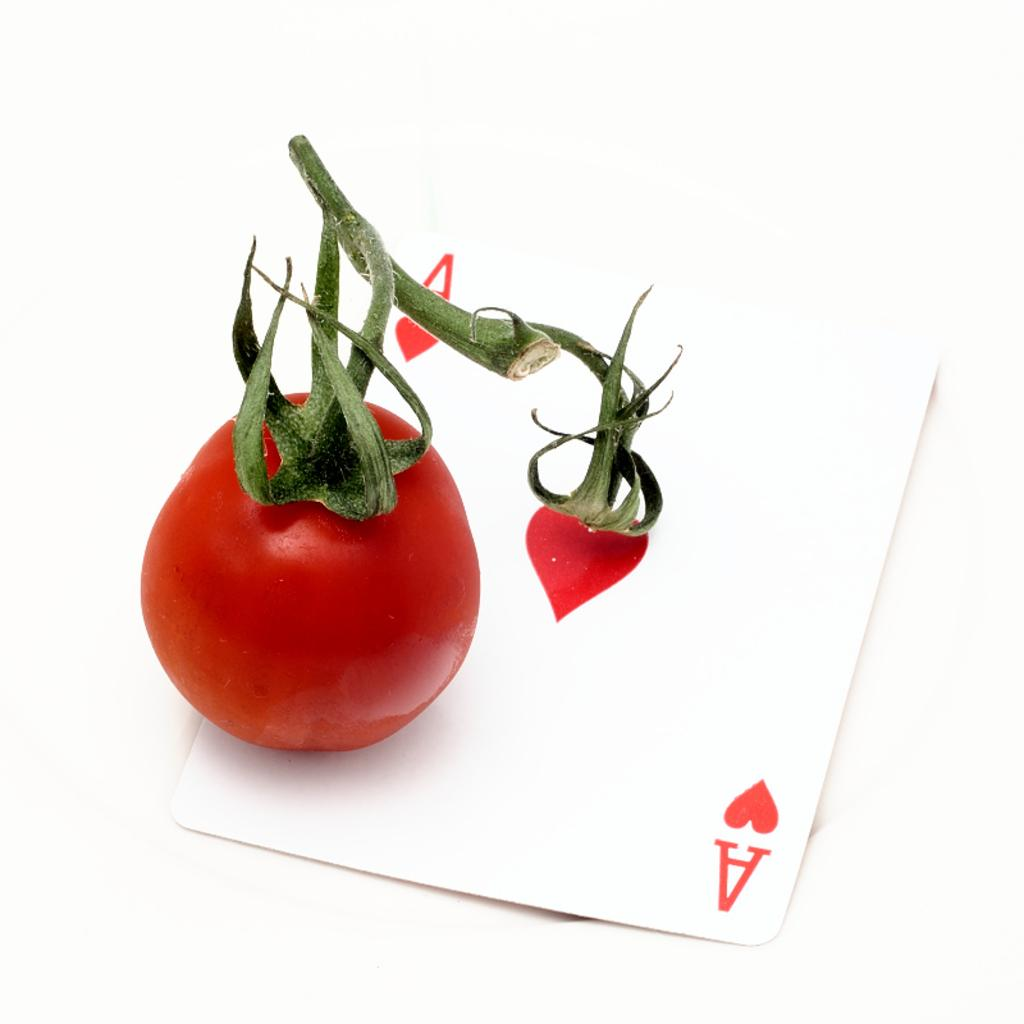What is depicted on the playing card in the image? There is a playing card in the image, and it has a tomato on it. What color is the tomato on the playing card? The tomato on the playing card is red in color. How many sugar cubes are on the playing card in the image? There are no sugar cubes present on the playing card in the image; it features a tomato instead. 